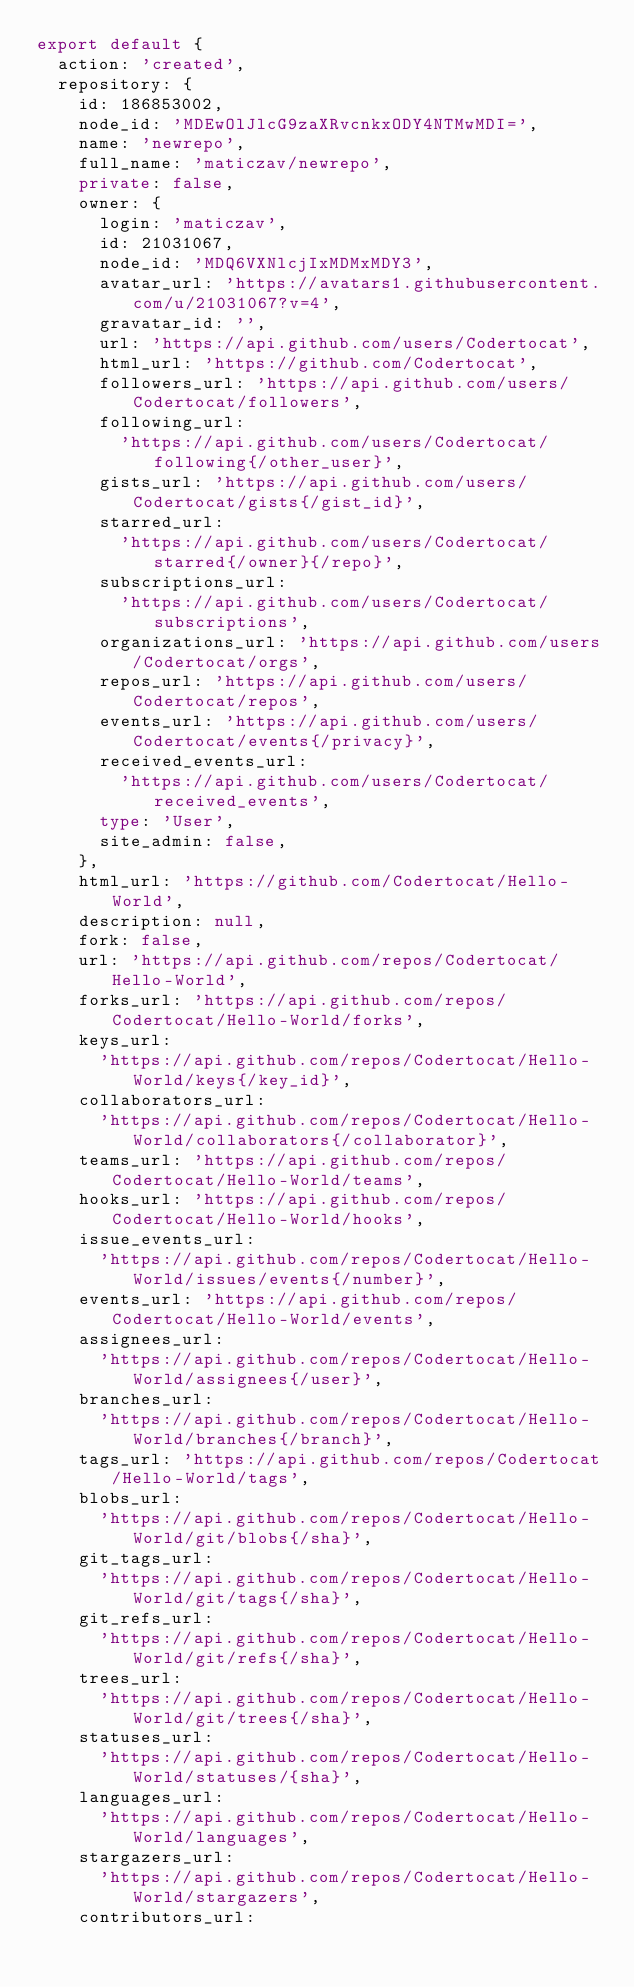<code> <loc_0><loc_0><loc_500><loc_500><_TypeScript_>export default {
  action: 'created',
  repository: {
    id: 186853002,
    node_id: 'MDEwOlJlcG9zaXRvcnkxODY4NTMwMDI=',
    name: 'newrepo',
    full_name: 'maticzav/newrepo',
    private: false,
    owner: {
      login: 'maticzav',
      id: 21031067,
      node_id: 'MDQ6VXNlcjIxMDMxMDY3',
      avatar_url: 'https://avatars1.githubusercontent.com/u/21031067?v=4',
      gravatar_id: '',
      url: 'https://api.github.com/users/Codertocat',
      html_url: 'https://github.com/Codertocat',
      followers_url: 'https://api.github.com/users/Codertocat/followers',
      following_url:
        'https://api.github.com/users/Codertocat/following{/other_user}',
      gists_url: 'https://api.github.com/users/Codertocat/gists{/gist_id}',
      starred_url:
        'https://api.github.com/users/Codertocat/starred{/owner}{/repo}',
      subscriptions_url:
        'https://api.github.com/users/Codertocat/subscriptions',
      organizations_url: 'https://api.github.com/users/Codertocat/orgs',
      repos_url: 'https://api.github.com/users/Codertocat/repos',
      events_url: 'https://api.github.com/users/Codertocat/events{/privacy}',
      received_events_url:
        'https://api.github.com/users/Codertocat/received_events',
      type: 'User',
      site_admin: false,
    },
    html_url: 'https://github.com/Codertocat/Hello-World',
    description: null,
    fork: false,
    url: 'https://api.github.com/repos/Codertocat/Hello-World',
    forks_url: 'https://api.github.com/repos/Codertocat/Hello-World/forks',
    keys_url:
      'https://api.github.com/repos/Codertocat/Hello-World/keys{/key_id}',
    collaborators_url:
      'https://api.github.com/repos/Codertocat/Hello-World/collaborators{/collaborator}',
    teams_url: 'https://api.github.com/repos/Codertocat/Hello-World/teams',
    hooks_url: 'https://api.github.com/repos/Codertocat/Hello-World/hooks',
    issue_events_url:
      'https://api.github.com/repos/Codertocat/Hello-World/issues/events{/number}',
    events_url: 'https://api.github.com/repos/Codertocat/Hello-World/events',
    assignees_url:
      'https://api.github.com/repos/Codertocat/Hello-World/assignees{/user}',
    branches_url:
      'https://api.github.com/repos/Codertocat/Hello-World/branches{/branch}',
    tags_url: 'https://api.github.com/repos/Codertocat/Hello-World/tags',
    blobs_url:
      'https://api.github.com/repos/Codertocat/Hello-World/git/blobs{/sha}',
    git_tags_url:
      'https://api.github.com/repos/Codertocat/Hello-World/git/tags{/sha}',
    git_refs_url:
      'https://api.github.com/repos/Codertocat/Hello-World/git/refs{/sha}',
    trees_url:
      'https://api.github.com/repos/Codertocat/Hello-World/git/trees{/sha}',
    statuses_url:
      'https://api.github.com/repos/Codertocat/Hello-World/statuses/{sha}',
    languages_url:
      'https://api.github.com/repos/Codertocat/Hello-World/languages',
    stargazers_url:
      'https://api.github.com/repos/Codertocat/Hello-World/stargazers',
    contributors_url:</code> 